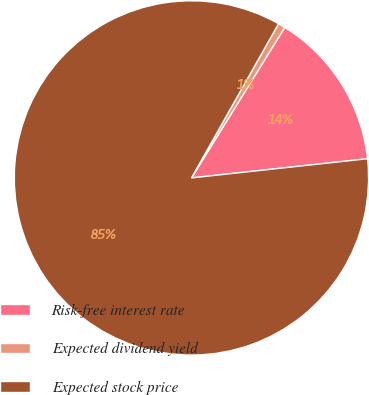<chart> <loc_0><loc_0><loc_500><loc_500><pie_chart><fcel>Risk-free interest rate<fcel>Expected dividend yield<fcel>Expected stock price<nl><fcel>14.44%<fcel>0.65%<fcel>84.92%<nl></chart> 